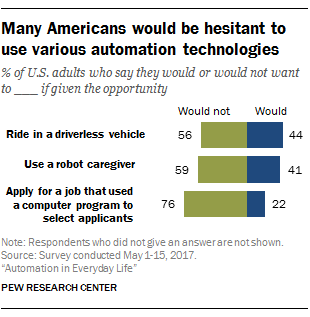Give some essential details in this illustration. The color of the bar whose smallest value is 22 is blue. The median values of the blue and green bars are being taken, and the ratio of the larger to the smaller value is being calculated. The result is being rounded to one decimal place. 